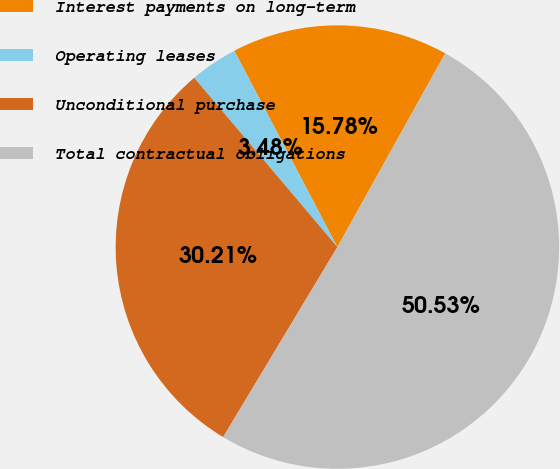Convert chart. <chart><loc_0><loc_0><loc_500><loc_500><pie_chart><fcel>Interest payments on long-term<fcel>Operating leases<fcel>Unconditional purchase<fcel>Total contractual obligations<nl><fcel>15.78%<fcel>3.48%<fcel>30.21%<fcel>50.53%<nl></chart> 